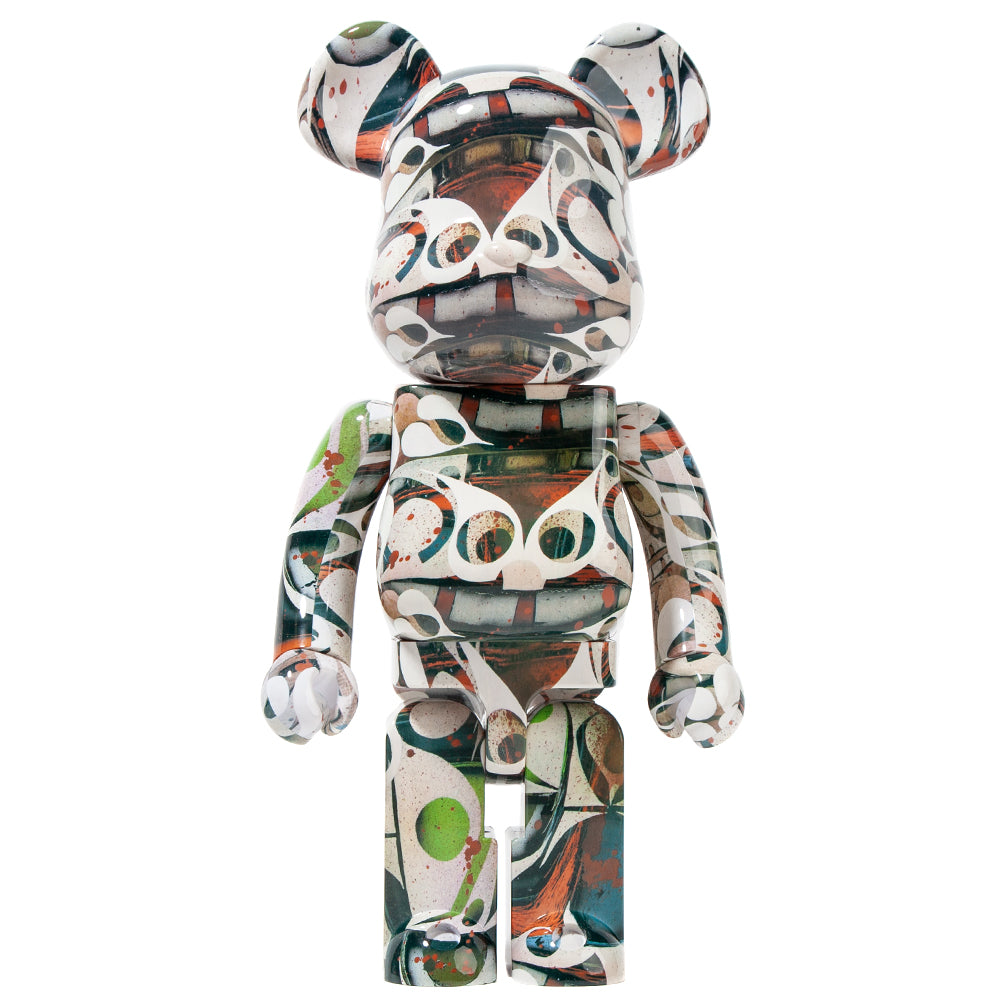Can you describe any cultural or historical influences that might be present in the design of this figurine? The design of this figurine may draw from mid-20th century art movements, particularly abstract expressionism which emerged in the United States. The abstract patterns and vibrant colors suggest a focus on individual expression, a core theme in this movement. Artists like Jackson Pollock, known for his innovative drip painting, may have inspired the design. Additionally, the use of repetitive curvilinear shapes might reflect influences from other abstract art traditions, possibly including European avant-garde styles such as surrealism or cubism. The figurine could also be synthesizing contemporary design trends that blend nostalgia with modern artistic techniques, creating a unique piece that resonates with both historical and present-day creative expressions.  How could the design of this figurine be representative of contemporary art practices? The figurine's design showcases elements that are synonymous with contemporary art practices. Contemporary art often blends diverse influences, ranging from past art movements to current pop culture and digital aesthetics. The use of bold colors and abstract patterns reflects contemporary artists' embrace of varied media and techniques, emphasizing personal expression and eccentricity. The figurine’s surface design, with its seemingly chaotic yet harmonized color palette and abstract forms, aligns with postmodern themes of juxtaposition and eclecticism. This representation might illustrate a confluence of street art, digital design, and abstract art, embodying a hybrid visual language that speaks to today's interconnected and multifaceted cultural landscape. 